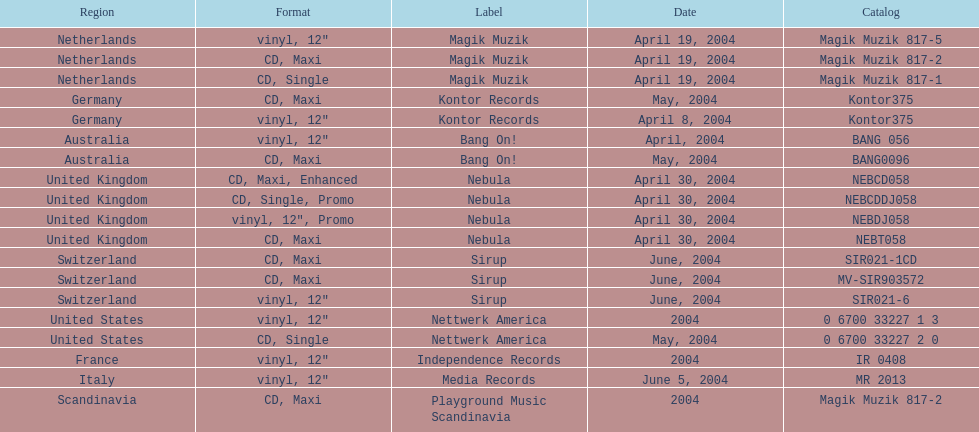What region is above australia? Germany. Would you be able to parse every entry in this table? {'header': ['Region', 'Format', 'Label', 'Date', 'Catalog'], 'rows': [['Netherlands', 'vinyl, 12"', 'Magik Muzik', 'April 19, 2004', 'Magik Muzik 817-5'], ['Netherlands', 'CD, Maxi', 'Magik Muzik', 'April 19, 2004', 'Magik Muzik 817-2'], ['Netherlands', 'CD, Single', 'Magik Muzik', 'April 19, 2004', 'Magik Muzik 817-1'], ['Germany', 'CD, Maxi', 'Kontor Records', 'May, 2004', 'Kontor375'], ['Germany', 'vinyl, 12"', 'Kontor Records', 'April 8, 2004', 'Kontor375'], ['Australia', 'vinyl, 12"', 'Bang On!', 'April, 2004', 'BANG 056'], ['Australia', 'CD, Maxi', 'Bang On!', 'May, 2004', 'BANG0096'], ['United Kingdom', 'CD, Maxi, Enhanced', 'Nebula', 'April 30, 2004', 'NEBCD058'], ['United Kingdom', 'CD, Single, Promo', 'Nebula', 'April 30, 2004', 'NEBCDDJ058'], ['United Kingdom', 'vinyl, 12", Promo', 'Nebula', 'April 30, 2004', 'NEBDJ058'], ['United Kingdom', 'CD, Maxi', 'Nebula', 'April 30, 2004', 'NEBT058'], ['Switzerland', 'CD, Maxi', 'Sirup', 'June, 2004', 'SIR021-1CD'], ['Switzerland', 'CD, Maxi', 'Sirup', 'June, 2004', 'MV-SIR903572'], ['Switzerland', 'vinyl, 12"', 'Sirup', 'June, 2004', 'SIR021-6'], ['United States', 'vinyl, 12"', 'Nettwerk America', '2004', '0 6700 33227 1 3'], ['United States', 'CD, Single', 'Nettwerk America', 'May, 2004', '0 6700 33227 2 0'], ['France', 'vinyl, 12"', 'Independence Records', '2004', 'IR 0408'], ['Italy', 'vinyl, 12"', 'Media Records', 'June 5, 2004', 'MR 2013'], ['Scandinavia', 'CD, Maxi', 'Playground Music Scandinavia', '2004', 'Magik Muzik 817-2']]} 